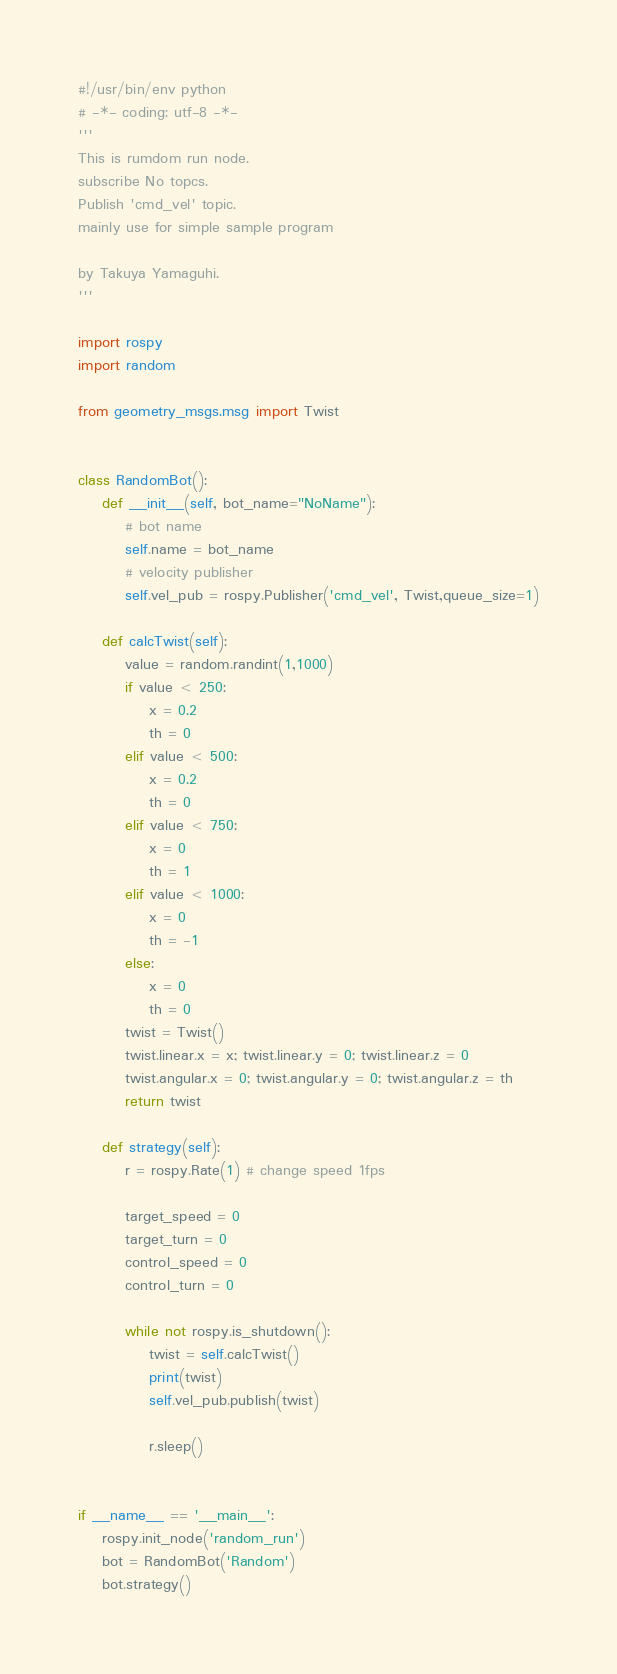<code> <loc_0><loc_0><loc_500><loc_500><_Python_>#!/usr/bin/env python
# -*- coding: utf-8 -*-
'''
This is rumdom run node.
subscribe No topcs.
Publish 'cmd_vel' topic. 
mainly use for simple sample program

by Takuya Yamaguhi.
'''

import rospy
import random

from geometry_msgs.msg import Twist


class RandomBot():
    def __init__(self, bot_name="NoName"):
        # bot name 
        self.name = bot_name
        # velocity publisher
        self.vel_pub = rospy.Publisher('cmd_vel', Twist,queue_size=1)

    def calcTwist(self):
        value = random.randint(1,1000)
        if value < 250:
            x = 0.2
            th = 0
        elif value < 500:
            x = 0.2
            th = 0
        elif value < 750:
            x = 0
            th = 1
        elif value < 1000:
            x = 0
            th = -1
        else:
            x = 0
            th = 0
        twist = Twist()
        twist.linear.x = x; twist.linear.y = 0; twist.linear.z = 0
        twist.angular.x = 0; twist.angular.y = 0; twist.angular.z = th
        return twist

    def strategy(self):
        r = rospy.Rate(1) # change speed 1fps

        target_speed = 0
        target_turn = 0
        control_speed = 0
        control_turn = 0

        while not rospy.is_shutdown():
            twist = self.calcTwist()
            print(twist)
            self.vel_pub.publish(twist)

            r.sleep()


if __name__ == '__main__':
    rospy.init_node('random_run')
    bot = RandomBot('Random')
    bot.strategy()

</code> 